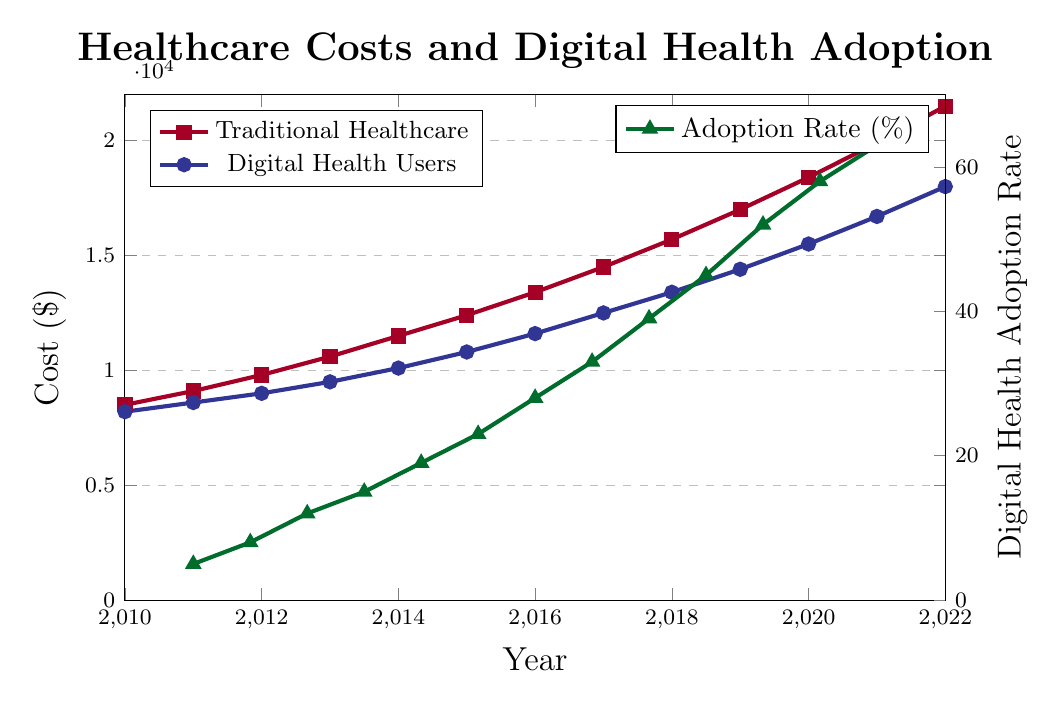How do the healthcare costs for seniors compare between traditional and digital health users in 2020? In 2020, the traditional healthcare cost is $18,400, while the digital health users cost is $15,500. Comparing these values, traditional healthcare costs are higher by $18,400 - $15,500 = $2,900.
Answer: $2,900 What is the trend in the healthcare costs for both traditional and digital health users from 2010 to 2022? Both traditional and digital health users' costs increase over time. The traditional healthcare cost increases from $8,500 in 2010 to $21,500 in 2022, and the digital health users' cost increases from $8,200 in 2010 to $18,000 in 2022. The overall trend for both groups is an upward trajectory.
Answer: Upward How much did the digital health adoption rate increase from 2010 to 2022? The digital health adoption rate was 5% in 2010 and increased to 63% in 2022. The difference between the two rates is 63% - 5% = 58%.
Answer: 58% Which year shows the highest difference in healthcare costs between traditional and digital health users, and what is that difference? To find the highest difference, we subtract the costs for each year and identify the largest value. The maximum difference is in 2022, where traditional healthcare costs $21,500 and digital health users cost $18,000. The difference is $21,500 - $18,000 = $3,500.
Answer: 2022, $3,500 What was the digital health adoption rate in 2015, and how do traditional and digital health costs compare that year? In 2015, the adoption rate is 23%. Traditional healthcare cost is $12,400, and digital health users cost is $10,800. The difference is $12,400 - $10,800 = $1,600.
Answer: 23%, $1,600 How did healthcare costs for traditional healthcare compare between 2011 and 2021? The traditional healthcare cost in 2011 is $9,100 and in 2021, it is $19,900. The difference is $19,900 - $9,100 = $10,800.
Answer: $10,800 On average, how much less did digital health users spend on healthcare compared to traditional healthcare users over the 13 years? First, calculate the yearly differences: 
2010: $8500 - $8200 = $300, 
2011: $9100 - $8600 = $500, 
2012: $9800 - $9000 = $800, 
2013: $10600 - $9500 = $1100, 
2014: $11500 - $10100 = $1400, 
2015: $12400 - $10800 = $1600, 
2016: $13400 - $11600 = $1800, 
2017: $14500 - $12500 = $2000, 
2018: $15700 - $13400 = $2300, 
2019: $17000 - $14400 = $2600, 
2020: $18400 - $15500 = $2900, 
2021: $19900 - $16700 = $3200, 
2022: $21500 - $18000 = $3500. 
Sum of differences = $21200. Average difference = $21200 / 13 = $1630.77.
Answer: $1,630.77 What was the percentage increase in traditional healthcare cost from 2016 to 2019? Traditional healthcare cost in 2016 was $13,400 and in 2019, it is $17,000. Percentage increase = [(17000 - 13400) / 13400] * 100 = 26.87%.
Answer: 26.87% By how much did the digital health adoption rate increase between 2017 and 2020? The adoption rate in 2017 is 33%, and in 2020, it is 52%. The increase is 52% - 33% = 19%.
Answer: 19% 